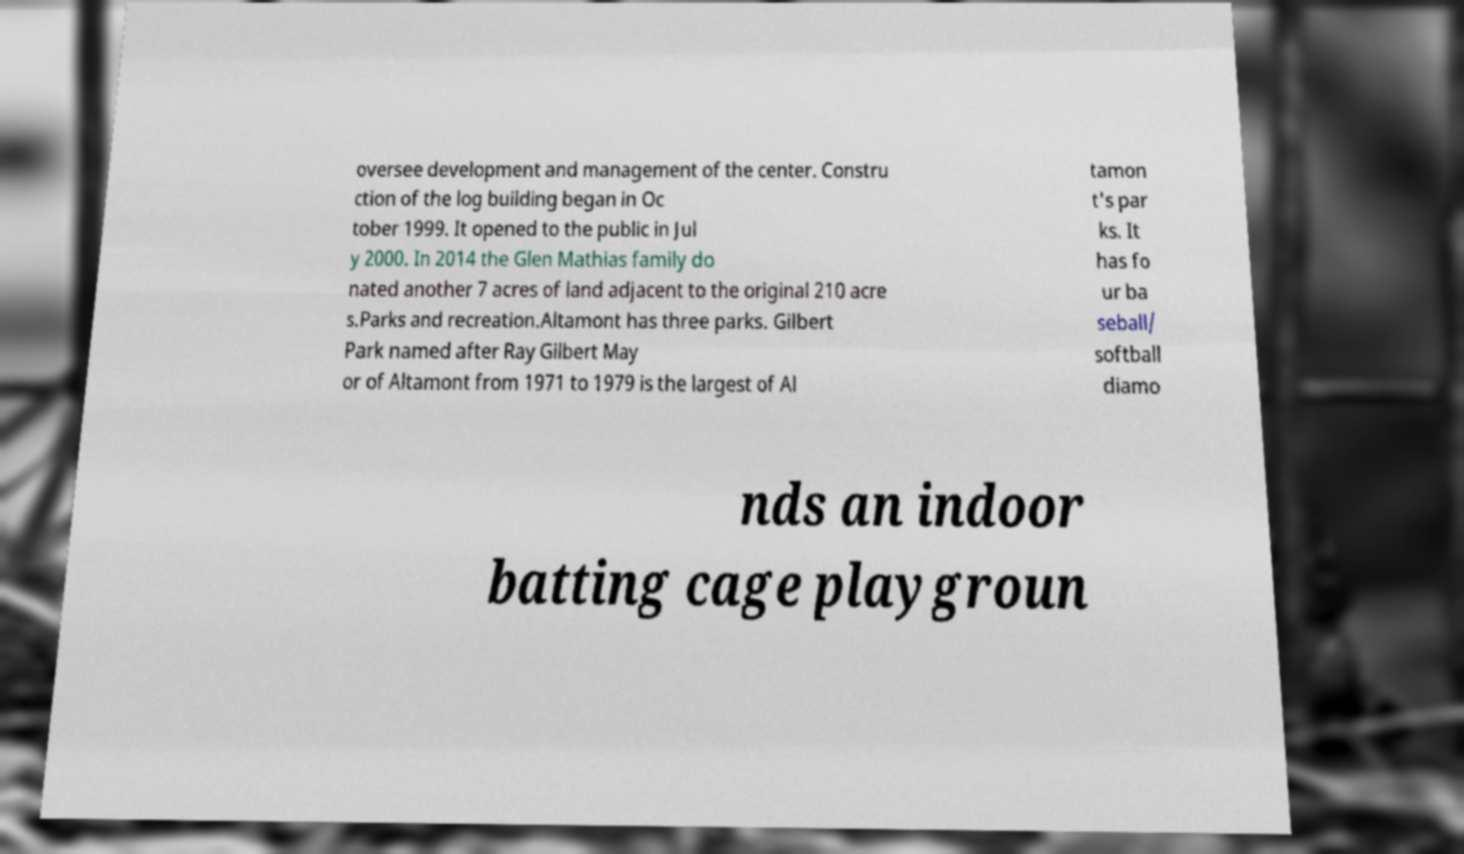Could you extract and type out the text from this image? oversee development and management of the center. Constru ction of the log building began in Oc tober 1999. It opened to the public in Jul y 2000. In 2014 the Glen Mathias family do nated another 7 acres of land adjacent to the original 210 acre s.Parks and recreation.Altamont has three parks. Gilbert Park named after Ray Gilbert May or of Altamont from 1971 to 1979 is the largest of Al tamon t's par ks. It has fo ur ba seball/ softball diamo nds an indoor batting cage playgroun 